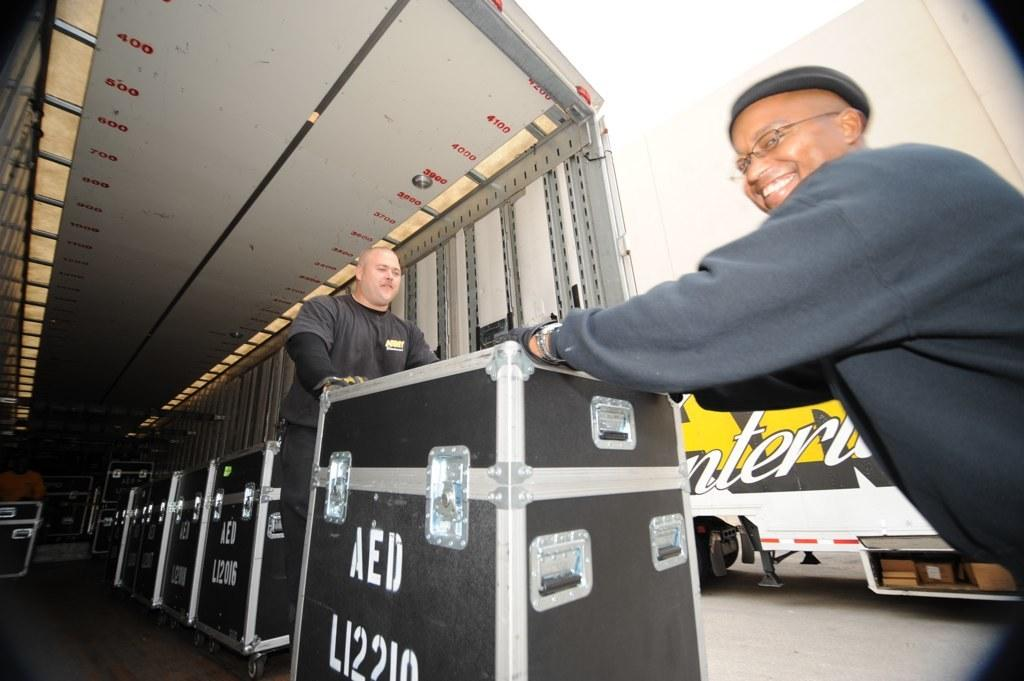How many people are in the image? There are two people in the image. What else can be seen in the image besides the people? There are boxes in the image. What type of jelly is being served by the servant in the image? There is no servant or jelly present in the image. What type of furniture is visible in the image? The provided facts do not mention any furniture, such as a sofa, in the image. 